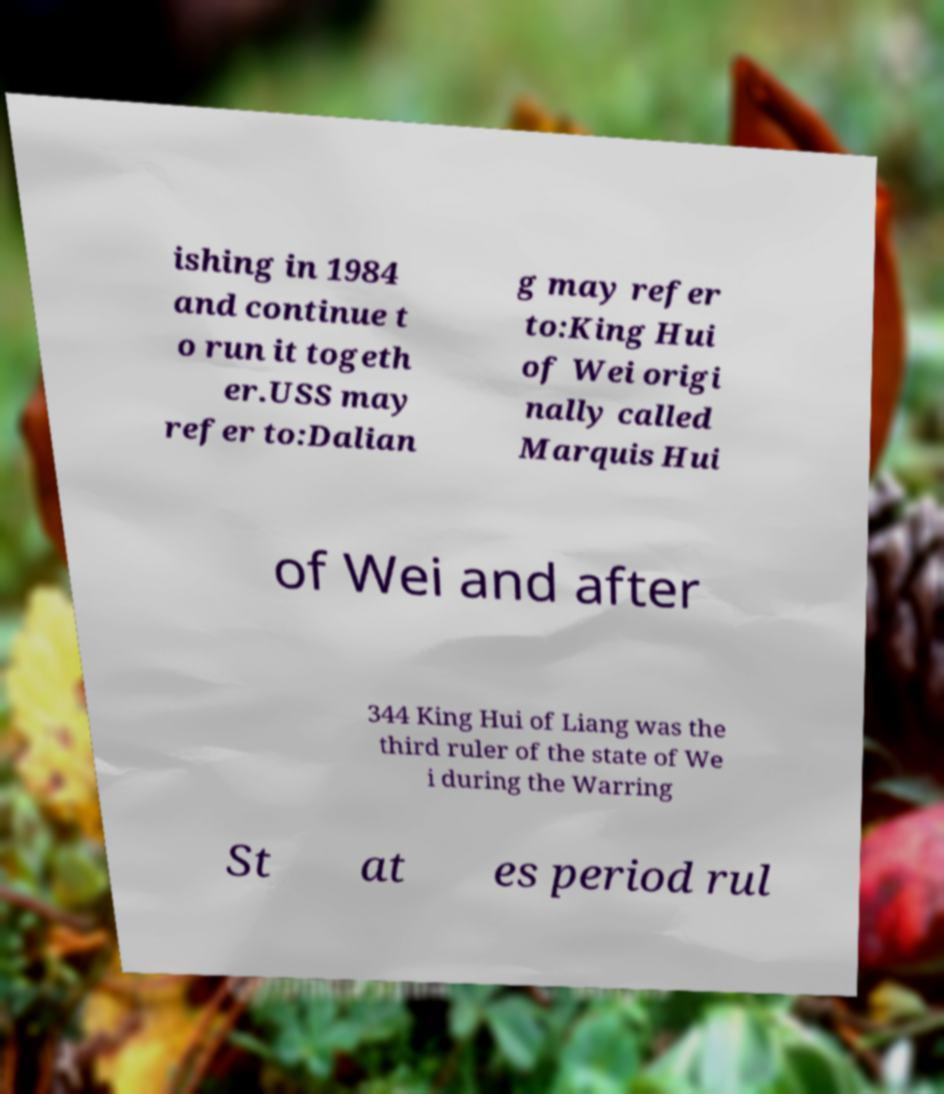What messages or text are displayed in this image? I need them in a readable, typed format. ishing in 1984 and continue t o run it togeth er.USS may refer to:Dalian g may refer to:King Hui of Wei origi nally called Marquis Hui of Wei and after 344 King Hui of Liang was the third ruler of the state of We i during the Warring St at es period rul 